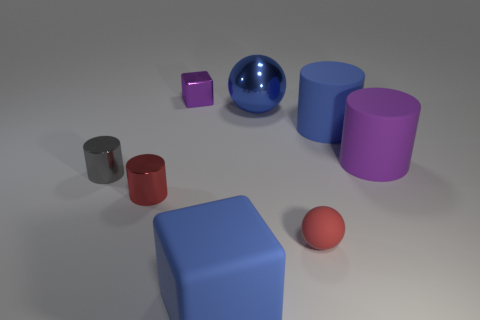The cylinder that is the same color as the small matte object is what size?
Offer a terse response. Small. How many cylinders have the same color as the large metal sphere?
Provide a succinct answer. 1. How many small things are metal cylinders or gray rubber blocks?
Provide a succinct answer. 2. There is a large cylinder that is the same color as the large metal object; what is its material?
Offer a very short reply. Rubber. Is there a small red sphere made of the same material as the large cube?
Make the answer very short. Yes. There is a purple object that is on the left side of the blue block; is it the same size as the gray metallic cylinder?
Make the answer very short. Yes. There is a cube in front of the purple thing that is in front of the purple metal thing; are there any red matte spheres that are in front of it?
Provide a succinct answer. No. What number of matte things are either large purple spheres or big purple cylinders?
Your answer should be very brief. 1. How many other objects are there of the same shape as the red matte thing?
Your answer should be compact. 1. Is the number of large blue blocks greater than the number of large yellow metal things?
Provide a short and direct response. Yes. 